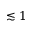<formula> <loc_0><loc_0><loc_500><loc_500>\lesssim 1</formula> 